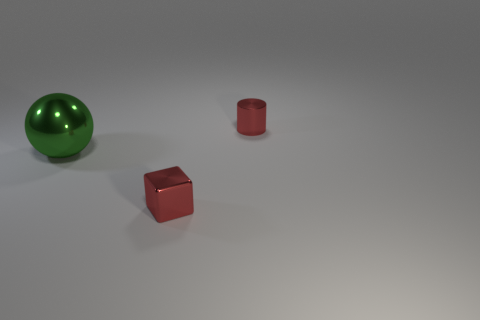Add 3 tiny objects. How many objects exist? 6 Subtract all cylinders. How many objects are left? 2 Subtract 1 spheres. How many spheres are left? 0 Add 2 small red spheres. How many small red spheres exist? 2 Subtract 0 gray cylinders. How many objects are left? 3 Subtract all yellow blocks. Subtract all gray cylinders. How many blocks are left? 1 Subtract all large metallic spheres. Subtract all big green metal objects. How many objects are left? 1 Add 3 spheres. How many spheres are left? 4 